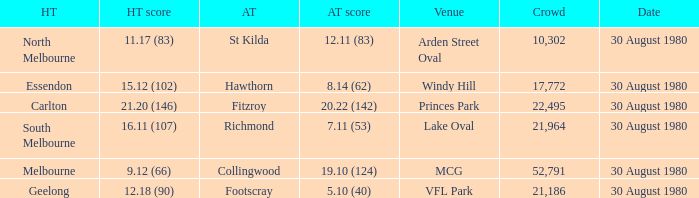What is the home team score at lake oval? 16.11 (107). 